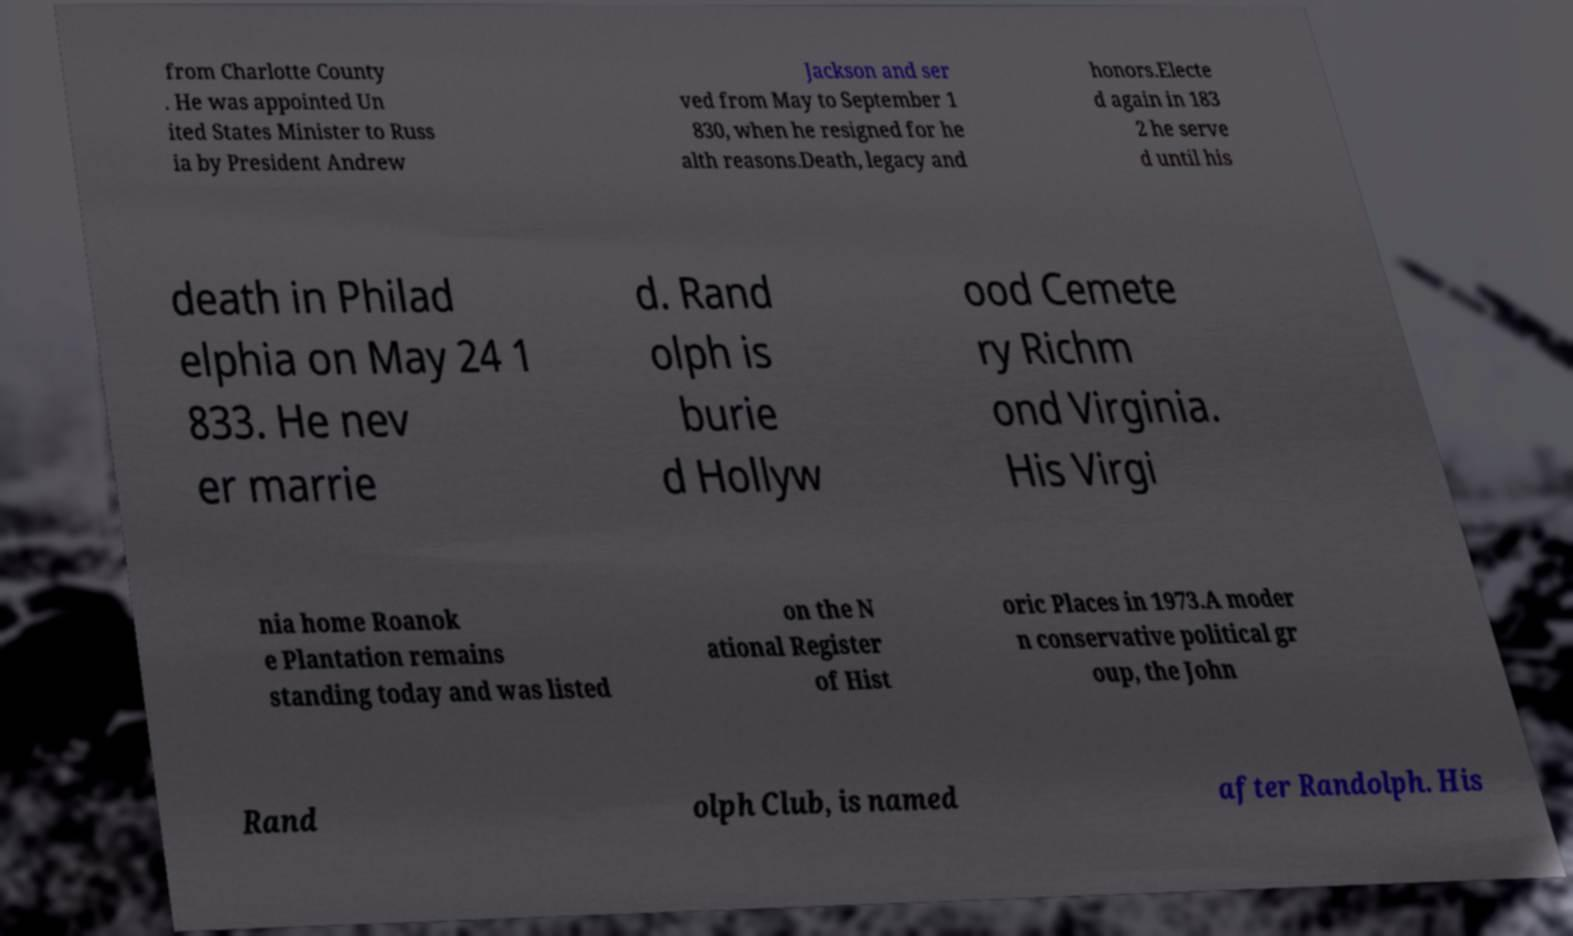Could you extract and type out the text from this image? from Charlotte County . He was appointed Un ited States Minister to Russ ia by President Andrew Jackson and ser ved from May to September 1 830, when he resigned for he alth reasons.Death, legacy and honors.Electe d again in 183 2 he serve d until his death in Philad elphia on May 24 1 833. He nev er marrie d. Rand olph is burie d Hollyw ood Cemete ry Richm ond Virginia. His Virgi nia home Roanok e Plantation remains standing today and was listed on the N ational Register of Hist oric Places in 1973.A moder n conservative political gr oup, the John Rand olph Club, is named after Randolph. His 